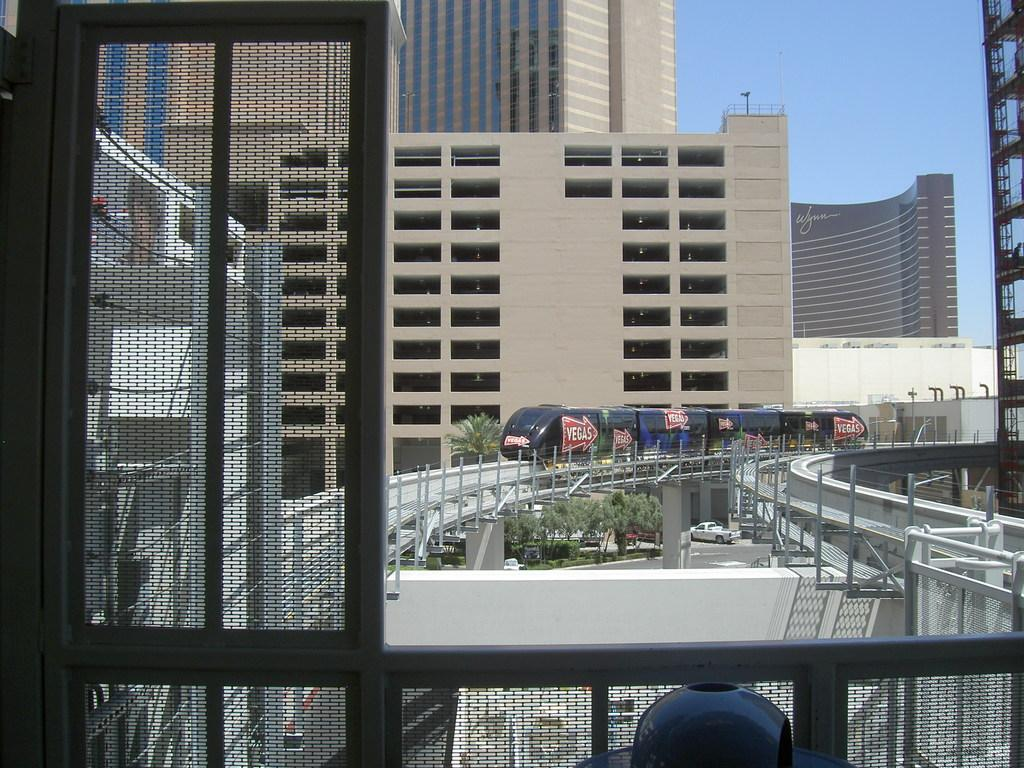What is the main subject of the image? There is a train on the railway track in the image. What can be seen in the background of the image? The sky is visible in the background of the image. What other structures are present in the image? There are trees, buildings, and vehicles on the road in the image. Can you see any bees flying around the train in the image? There are no bees present in the image. What is the elbow's role in the operation of the train in the image? There is no mention of an elbow in the image, as it is not a part of a train or related to its operation. 